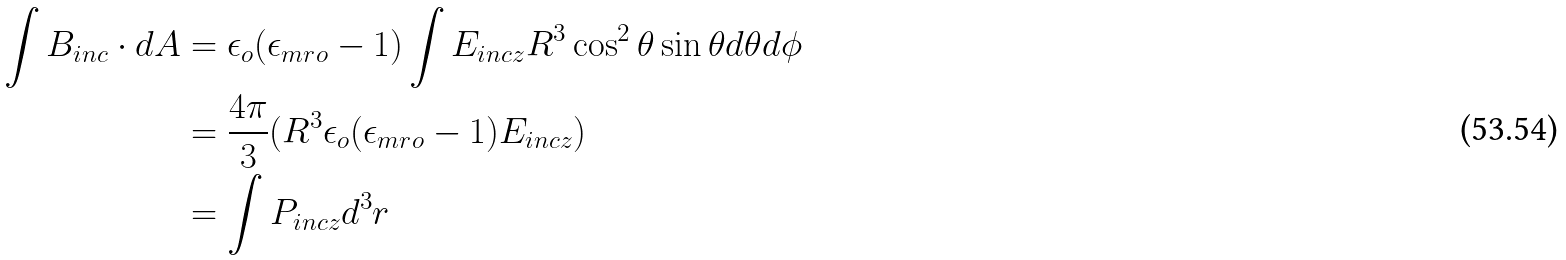Convert formula to latex. <formula><loc_0><loc_0><loc_500><loc_500>\int { B } _ { i n c } \cdot d { A } & = \epsilon _ { o } ( \epsilon _ { m r o } - 1 ) \int E _ { i n c z } R ^ { 3 } \cos ^ { 2 } \theta \sin \theta d \theta d \phi \\ & = \frac { 4 \pi } { 3 } ( R ^ { 3 } \epsilon _ { o } ( \epsilon _ { m r o } - 1 ) E _ { i n c z } ) \\ & = \int P _ { i n c z } d ^ { 3 } r</formula> 